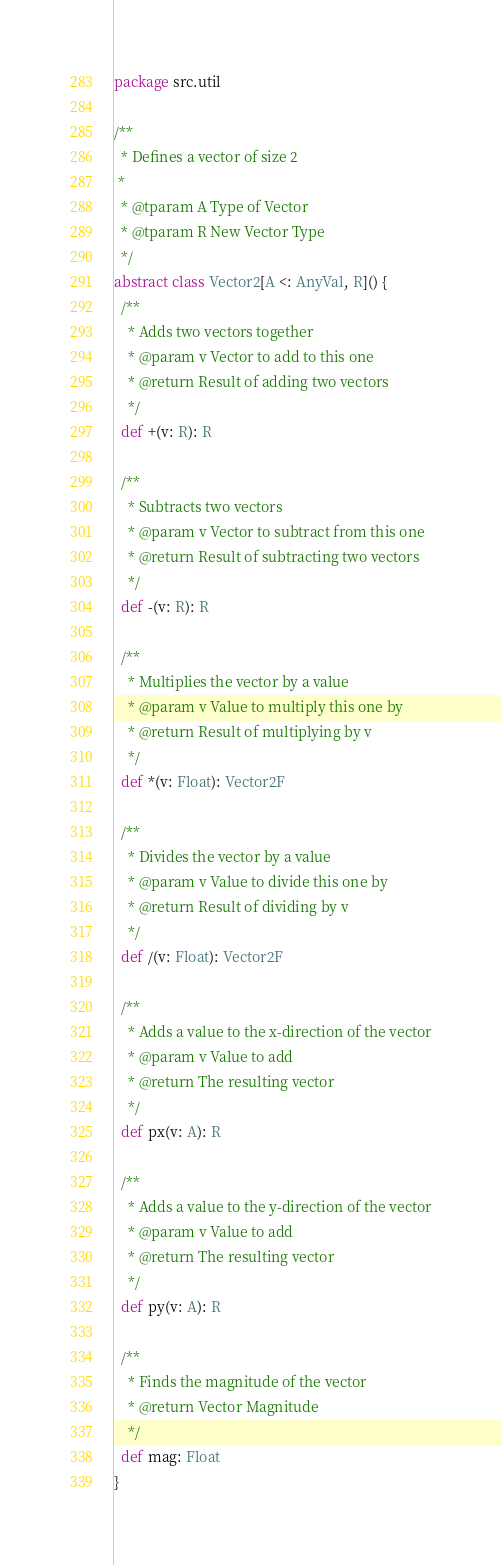<code> <loc_0><loc_0><loc_500><loc_500><_Scala_>package src.util

/**
  * Defines a vector of size 2
 *
  * @tparam A Type of Vector
  * @tparam R New Vector Type
  */
abstract class Vector2[A <: AnyVal, R]() {
  /**
    * Adds two vectors together
    * @param v Vector to add to this one
    * @return Result of adding two vectors
    */
  def +(v: R): R

  /**
    * Subtracts two vectors
    * @param v Vector to subtract from this one
    * @return Result of subtracting two vectors
    */
  def -(v: R): R

  /**
    * Multiplies the vector by a value
    * @param v Value to multiply this one by
    * @return Result of multiplying by v
    */
  def *(v: Float): Vector2F

  /**
    * Divides the vector by a value
    * @param v Value to divide this one by
    * @return Result of dividing by v
    */
  def /(v: Float): Vector2F

  /**
    * Adds a value to the x-direction of the vector
    * @param v Value to add
    * @return The resulting vector
    */
  def px(v: A): R

  /**
    * Adds a value to the y-direction of the vector
    * @param v Value to add
    * @return The resulting vector
    */
  def py(v: A): R

  /**
    * Finds the magnitude of the vector
    * @return Vector Magnitude
    */
  def mag: Float
}
</code> 